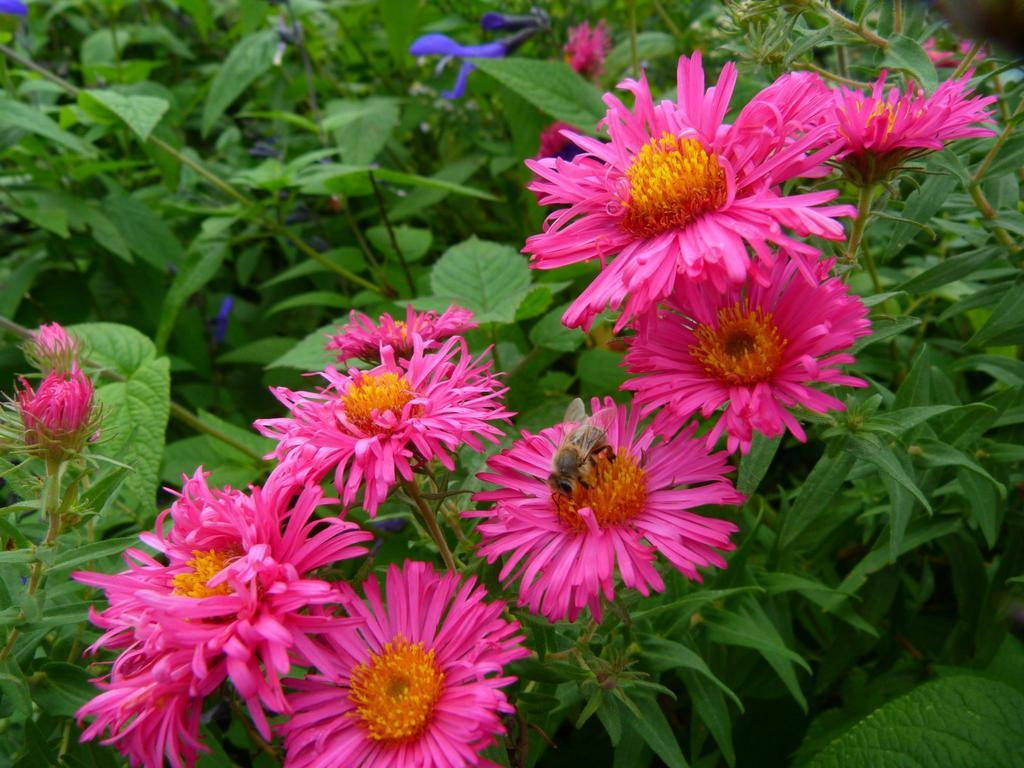What type of vegetation can be seen in the image? There are plants with flowers in the image. What other parts of the plants are visible besides the flowers? Leaves are visible at the bottom of the plants in the image. How does the cabbage shake in the image? There is no cabbage present in the image, so it cannot shake. 